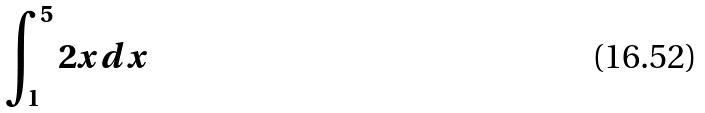Convert formula to latex. <formula><loc_0><loc_0><loc_500><loc_500>\int _ { 1 } ^ { 5 } 2 x d x</formula> 